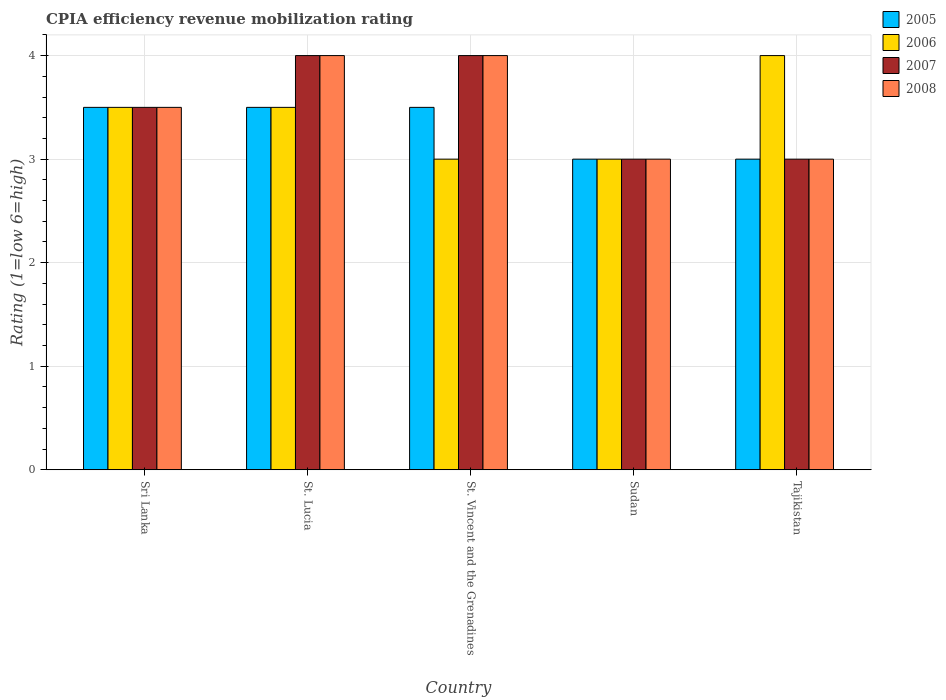How many different coloured bars are there?
Keep it short and to the point. 4. Are the number of bars on each tick of the X-axis equal?
Ensure brevity in your answer.  Yes. How many bars are there on the 4th tick from the right?
Make the answer very short. 4. What is the label of the 1st group of bars from the left?
Provide a succinct answer. Sri Lanka. What is the CPIA rating in 2005 in Tajikistan?
Your response must be concise. 3. Across all countries, what is the maximum CPIA rating in 2008?
Offer a very short reply. 4. In which country was the CPIA rating in 2005 maximum?
Make the answer very short. Sri Lanka. In which country was the CPIA rating in 2007 minimum?
Your answer should be compact. Sudan. What is the average CPIA rating in 2005 per country?
Provide a short and direct response. 3.3. In how many countries, is the CPIA rating in 2008 greater than 2?
Your response must be concise. 5. What is the ratio of the CPIA rating in 2008 in St. Lucia to that in Sudan?
Offer a terse response. 1.33. Is the difference between the CPIA rating in 2008 in Sri Lanka and St. Vincent and the Grenadines greater than the difference between the CPIA rating in 2005 in Sri Lanka and St. Vincent and the Grenadines?
Offer a terse response. No. What does the 1st bar from the left in Tajikistan represents?
Offer a very short reply. 2005. Is it the case that in every country, the sum of the CPIA rating in 2007 and CPIA rating in 2006 is greater than the CPIA rating in 2005?
Offer a very short reply. Yes. What is the difference between two consecutive major ticks on the Y-axis?
Give a very brief answer. 1. Are the values on the major ticks of Y-axis written in scientific E-notation?
Make the answer very short. No. Does the graph contain grids?
Your response must be concise. Yes. What is the title of the graph?
Your answer should be compact. CPIA efficiency revenue mobilization rating. What is the label or title of the X-axis?
Provide a short and direct response. Country. What is the label or title of the Y-axis?
Make the answer very short. Rating (1=low 6=high). What is the Rating (1=low 6=high) in 2007 in Sri Lanka?
Your response must be concise. 3.5. What is the Rating (1=low 6=high) in 2008 in Sri Lanka?
Ensure brevity in your answer.  3.5. What is the Rating (1=low 6=high) of 2007 in St. Lucia?
Provide a succinct answer. 4. What is the Rating (1=low 6=high) in 2008 in St. Lucia?
Provide a short and direct response. 4. What is the Rating (1=low 6=high) in 2005 in St. Vincent and the Grenadines?
Your answer should be compact. 3.5. What is the Rating (1=low 6=high) in 2007 in St. Vincent and the Grenadines?
Make the answer very short. 4. What is the Rating (1=low 6=high) in 2005 in Sudan?
Your answer should be very brief. 3. What is the Rating (1=low 6=high) of 2005 in Tajikistan?
Keep it short and to the point. 3. What is the Rating (1=low 6=high) of 2007 in Tajikistan?
Your answer should be compact. 3. Across all countries, what is the maximum Rating (1=low 6=high) of 2007?
Keep it short and to the point. 4. Across all countries, what is the maximum Rating (1=low 6=high) of 2008?
Your response must be concise. 4. Across all countries, what is the minimum Rating (1=low 6=high) of 2005?
Keep it short and to the point. 3. Across all countries, what is the minimum Rating (1=low 6=high) of 2006?
Keep it short and to the point. 3. Across all countries, what is the minimum Rating (1=low 6=high) in 2007?
Provide a succinct answer. 3. What is the total Rating (1=low 6=high) of 2005 in the graph?
Your answer should be compact. 16.5. What is the total Rating (1=low 6=high) in 2008 in the graph?
Provide a short and direct response. 17.5. What is the difference between the Rating (1=low 6=high) in 2005 in Sri Lanka and that in St. Lucia?
Make the answer very short. 0. What is the difference between the Rating (1=low 6=high) of 2007 in Sri Lanka and that in St. Lucia?
Provide a succinct answer. -0.5. What is the difference between the Rating (1=low 6=high) of 2008 in Sri Lanka and that in St. Lucia?
Offer a terse response. -0.5. What is the difference between the Rating (1=low 6=high) in 2005 in Sri Lanka and that in St. Vincent and the Grenadines?
Give a very brief answer. 0. What is the difference between the Rating (1=low 6=high) in 2007 in Sri Lanka and that in St. Vincent and the Grenadines?
Your response must be concise. -0.5. What is the difference between the Rating (1=low 6=high) in 2008 in Sri Lanka and that in Sudan?
Ensure brevity in your answer.  0.5. What is the difference between the Rating (1=low 6=high) in 2005 in St. Lucia and that in St. Vincent and the Grenadines?
Your answer should be very brief. 0. What is the difference between the Rating (1=low 6=high) of 2005 in St. Lucia and that in Sudan?
Ensure brevity in your answer.  0.5. What is the difference between the Rating (1=low 6=high) of 2006 in St. Lucia and that in Sudan?
Your answer should be very brief. 0.5. What is the difference between the Rating (1=low 6=high) of 2006 in St. Lucia and that in Tajikistan?
Give a very brief answer. -0.5. What is the difference between the Rating (1=low 6=high) in 2008 in St. Lucia and that in Tajikistan?
Your answer should be compact. 1. What is the difference between the Rating (1=low 6=high) of 2005 in St. Vincent and the Grenadines and that in Sudan?
Provide a succinct answer. 0.5. What is the difference between the Rating (1=low 6=high) of 2006 in St. Vincent and the Grenadines and that in Sudan?
Provide a short and direct response. 0. What is the difference between the Rating (1=low 6=high) of 2008 in St. Vincent and the Grenadines and that in Sudan?
Provide a succinct answer. 1. What is the difference between the Rating (1=low 6=high) of 2005 in St. Vincent and the Grenadines and that in Tajikistan?
Provide a succinct answer. 0.5. What is the difference between the Rating (1=low 6=high) in 2007 in St. Vincent and the Grenadines and that in Tajikistan?
Ensure brevity in your answer.  1. What is the difference between the Rating (1=low 6=high) of 2005 in Sudan and that in Tajikistan?
Keep it short and to the point. 0. What is the difference between the Rating (1=low 6=high) of 2008 in Sudan and that in Tajikistan?
Offer a terse response. 0. What is the difference between the Rating (1=low 6=high) of 2007 in Sri Lanka and the Rating (1=low 6=high) of 2008 in St. Lucia?
Keep it short and to the point. -0.5. What is the difference between the Rating (1=low 6=high) in 2005 in Sri Lanka and the Rating (1=low 6=high) in 2006 in St. Vincent and the Grenadines?
Make the answer very short. 0.5. What is the difference between the Rating (1=low 6=high) in 2005 in Sri Lanka and the Rating (1=low 6=high) in 2008 in St. Vincent and the Grenadines?
Ensure brevity in your answer.  -0.5. What is the difference between the Rating (1=low 6=high) in 2006 in Sri Lanka and the Rating (1=low 6=high) in 2008 in St. Vincent and the Grenadines?
Provide a succinct answer. -0.5. What is the difference between the Rating (1=low 6=high) of 2005 in Sri Lanka and the Rating (1=low 6=high) of 2007 in Sudan?
Offer a terse response. 0.5. What is the difference between the Rating (1=low 6=high) of 2005 in Sri Lanka and the Rating (1=low 6=high) of 2008 in Sudan?
Ensure brevity in your answer.  0.5. What is the difference between the Rating (1=low 6=high) of 2006 in Sri Lanka and the Rating (1=low 6=high) of 2007 in Sudan?
Provide a succinct answer. 0.5. What is the difference between the Rating (1=low 6=high) of 2006 in Sri Lanka and the Rating (1=low 6=high) of 2008 in Sudan?
Ensure brevity in your answer.  0.5. What is the difference between the Rating (1=low 6=high) in 2005 in Sri Lanka and the Rating (1=low 6=high) in 2008 in Tajikistan?
Keep it short and to the point. 0.5. What is the difference between the Rating (1=low 6=high) of 2006 in Sri Lanka and the Rating (1=low 6=high) of 2007 in Tajikistan?
Your response must be concise. 0.5. What is the difference between the Rating (1=low 6=high) of 2007 in Sri Lanka and the Rating (1=low 6=high) of 2008 in Tajikistan?
Offer a terse response. 0.5. What is the difference between the Rating (1=low 6=high) of 2005 in St. Lucia and the Rating (1=low 6=high) of 2008 in St. Vincent and the Grenadines?
Provide a short and direct response. -0.5. What is the difference between the Rating (1=low 6=high) of 2007 in St. Lucia and the Rating (1=low 6=high) of 2008 in St. Vincent and the Grenadines?
Provide a succinct answer. 0. What is the difference between the Rating (1=low 6=high) of 2005 in St. Lucia and the Rating (1=low 6=high) of 2008 in Sudan?
Offer a very short reply. 0.5. What is the difference between the Rating (1=low 6=high) in 2006 in St. Lucia and the Rating (1=low 6=high) in 2007 in Sudan?
Your answer should be compact. 0.5. What is the difference between the Rating (1=low 6=high) of 2005 in St. Lucia and the Rating (1=low 6=high) of 2007 in Tajikistan?
Your answer should be compact. 0.5. What is the difference between the Rating (1=low 6=high) in 2006 in St. Lucia and the Rating (1=low 6=high) in 2007 in Tajikistan?
Make the answer very short. 0.5. What is the difference between the Rating (1=low 6=high) in 2007 in St. Lucia and the Rating (1=low 6=high) in 2008 in Tajikistan?
Provide a short and direct response. 1. What is the difference between the Rating (1=low 6=high) in 2005 in St. Vincent and the Grenadines and the Rating (1=low 6=high) in 2007 in Sudan?
Offer a terse response. 0.5. What is the difference between the Rating (1=low 6=high) in 2006 in St. Vincent and the Grenadines and the Rating (1=low 6=high) in 2007 in Sudan?
Keep it short and to the point. 0. What is the difference between the Rating (1=low 6=high) of 2007 in St. Vincent and the Grenadines and the Rating (1=low 6=high) of 2008 in Sudan?
Make the answer very short. 1. What is the difference between the Rating (1=low 6=high) in 2005 in St. Vincent and the Grenadines and the Rating (1=low 6=high) in 2006 in Tajikistan?
Provide a short and direct response. -0.5. What is the difference between the Rating (1=low 6=high) of 2005 in St. Vincent and the Grenadines and the Rating (1=low 6=high) of 2008 in Tajikistan?
Make the answer very short. 0.5. What is the difference between the Rating (1=low 6=high) in 2006 in St. Vincent and the Grenadines and the Rating (1=low 6=high) in 2008 in Tajikistan?
Offer a very short reply. 0. What is the difference between the Rating (1=low 6=high) in 2005 in Sudan and the Rating (1=low 6=high) in 2006 in Tajikistan?
Give a very brief answer. -1. What is the difference between the Rating (1=low 6=high) in 2005 in Sudan and the Rating (1=low 6=high) in 2007 in Tajikistan?
Keep it short and to the point. 0. What is the difference between the Rating (1=low 6=high) in 2006 in Sudan and the Rating (1=low 6=high) in 2008 in Tajikistan?
Make the answer very short. 0. What is the average Rating (1=low 6=high) of 2005 per country?
Ensure brevity in your answer.  3.3. What is the average Rating (1=low 6=high) in 2008 per country?
Your response must be concise. 3.5. What is the difference between the Rating (1=low 6=high) of 2005 and Rating (1=low 6=high) of 2006 in Sri Lanka?
Your answer should be compact. 0. What is the difference between the Rating (1=low 6=high) of 2005 and Rating (1=low 6=high) of 2007 in Sri Lanka?
Provide a succinct answer. 0. What is the difference between the Rating (1=low 6=high) of 2005 and Rating (1=low 6=high) of 2008 in Sri Lanka?
Keep it short and to the point. 0. What is the difference between the Rating (1=low 6=high) in 2006 and Rating (1=low 6=high) in 2007 in Sri Lanka?
Your answer should be compact. 0. What is the difference between the Rating (1=low 6=high) in 2007 and Rating (1=low 6=high) in 2008 in Sri Lanka?
Give a very brief answer. 0. What is the difference between the Rating (1=low 6=high) in 2005 and Rating (1=low 6=high) in 2007 in St. Lucia?
Make the answer very short. -0.5. What is the difference between the Rating (1=low 6=high) of 2006 and Rating (1=low 6=high) of 2007 in St. Lucia?
Your answer should be compact. -0.5. What is the difference between the Rating (1=low 6=high) of 2005 and Rating (1=low 6=high) of 2006 in St. Vincent and the Grenadines?
Your response must be concise. 0.5. What is the difference between the Rating (1=low 6=high) in 2006 and Rating (1=low 6=high) in 2007 in St. Vincent and the Grenadines?
Provide a short and direct response. -1. What is the difference between the Rating (1=low 6=high) in 2007 and Rating (1=low 6=high) in 2008 in St. Vincent and the Grenadines?
Your response must be concise. 0. What is the difference between the Rating (1=low 6=high) of 2005 and Rating (1=low 6=high) of 2006 in Sudan?
Provide a short and direct response. 0. What is the difference between the Rating (1=low 6=high) in 2005 and Rating (1=low 6=high) in 2008 in Sudan?
Give a very brief answer. 0. What is the difference between the Rating (1=low 6=high) of 2006 and Rating (1=low 6=high) of 2008 in Sudan?
Your answer should be very brief. 0. What is the difference between the Rating (1=low 6=high) of 2007 and Rating (1=low 6=high) of 2008 in Sudan?
Make the answer very short. 0. What is the difference between the Rating (1=low 6=high) in 2005 and Rating (1=low 6=high) in 2007 in Tajikistan?
Give a very brief answer. 0. What is the difference between the Rating (1=low 6=high) of 2005 and Rating (1=low 6=high) of 2008 in Tajikistan?
Give a very brief answer. 0. What is the difference between the Rating (1=low 6=high) in 2006 and Rating (1=low 6=high) in 2007 in Tajikistan?
Make the answer very short. 1. What is the difference between the Rating (1=low 6=high) of 2007 and Rating (1=low 6=high) of 2008 in Tajikistan?
Your response must be concise. 0. What is the ratio of the Rating (1=low 6=high) in 2006 in Sri Lanka to that in St. Lucia?
Make the answer very short. 1. What is the ratio of the Rating (1=low 6=high) of 2006 in Sri Lanka to that in St. Vincent and the Grenadines?
Your answer should be compact. 1.17. What is the ratio of the Rating (1=low 6=high) of 2008 in Sri Lanka to that in St. Vincent and the Grenadines?
Give a very brief answer. 0.88. What is the ratio of the Rating (1=low 6=high) in 2005 in Sri Lanka to that in Tajikistan?
Your response must be concise. 1.17. What is the ratio of the Rating (1=low 6=high) of 2005 in St. Lucia to that in St. Vincent and the Grenadines?
Offer a terse response. 1. What is the ratio of the Rating (1=low 6=high) of 2006 in St. Lucia to that in St. Vincent and the Grenadines?
Give a very brief answer. 1.17. What is the ratio of the Rating (1=low 6=high) of 2007 in St. Lucia to that in St. Vincent and the Grenadines?
Ensure brevity in your answer.  1. What is the ratio of the Rating (1=low 6=high) of 2008 in St. Lucia to that in St. Vincent and the Grenadines?
Your answer should be compact. 1. What is the ratio of the Rating (1=low 6=high) in 2006 in St. Lucia to that in Sudan?
Offer a very short reply. 1.17. What is the ratio of the Rating (1=low 6=high) of 2007 in St. Lucia to that in Sudan?
Provide a succinct answer. 1.33. What is the ratio of the Rating (1=low 6=high) of 2006 in St. Lucia to that in Tajikistan?
Keep it short and to the point. 0.88. What is the ratio of the Rating (1=low 6=high) of 2005 in St. Vincent and the Grenadines to that in Sudan?
Make the answer very short. 1.17. What is the ratio of the Rating (1=low 6=high) of 2006 in St. Vincent and the Grenadines to that in Sudan?
Provide a succinct answer. 1. What is the ratio of the Rating (1=low 6=high) in 2007 in St. Vincent and the Grenadines to that in Sudan?
Keep it short and to the point. 1.33. What is the ratio of the Rating (1=low 6=high) of 2008 in St. Vincent and the Grenadines to that in Sudan?
Give a very brief answer. 1.33. What is the ratio of the Rating (1=low 6=high) in 2005 in St. Vincent and the Grenadines to that in Tajikistan?
Your answer should be compact. 1.17. What is the ratio of the Rating (1=low 6=high) in 2008 in St. Vincent and the Grenadines to that in Tajikistan?
Your answer should be very brief. 1.33. What is the ratio of the Rating (1=low 6=high) of 2005 in Sudan to that in Tajikistan?
Your response must be concise. 1. What is the ratio of the Rating (1=low 6=high) of 2007 in Sudan to that in Tajikistan?
Your answer should be very brief. 1. What is the difference between the highest and the second highest Rating (1=low 6=high) of 2005?
Keep it short and to the point. 0. What is the difference between the highest and the second highest Rating (1=low 6=high) of 2006?
Give a very brief answer. 0.5. What is the difference between the highest and the second highest Rating (1=low 6=high) in 2007?
Keep it short and to the point. 0. What is the difference between the highest and the lowest Rating (1=low 6=high) in 2005?
Give a very brief answer. 0.5. What is the difference between the highest and the lowest Rating (1=low 6=high) in 2007?
Keep it short and to the point. 1. 